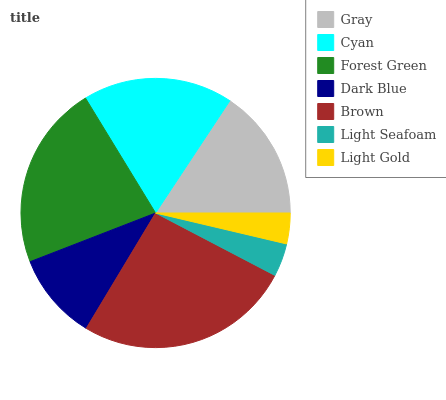Is Light Gold the minimum?
Answer yes or no. Yes. Is Brown the maximum?
Answer yes or no. Yes. Is Cyan the minimum?
Answer yes or no. No. Is Cyan the maximum?
Answer yes or no. No. Is Cyan greater than Gray?
Answer yes or no. Yes. Is Gray less than Cyan?
Answer yes or no. Yes. Is Gray greater than Cyan?
Answer yes or no. No. Is Cyan less than Gray?
Answer yes or no. No. Is Gray the high median?
Answer yes or no. Yes. Is Gray the low median?
Answer yes or no. Yes. Is Forest Green the high median?
Answer yes or no. No. Is Dark Blue the low median?
Answer yes or no. No. 